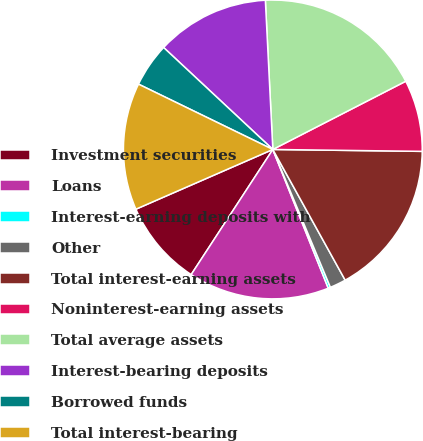Convert chart. <chart><loc_0><loc_0><loc_500><loc_500><pie_chart><fcel>Investment securities<fcel>Loans<fcel>Interest-earning deposits with<fcel>Other<fcel>Total interest-earning assets<fcel>Noninterest-earning assets<fcel>Total average assets<fcel>Interest-bearing deposits<fcel>Borrowed funds<fcel>Total interest-bearing<nl><fcel>9.25%<fcel>15.25%<fcel>0.25%<fcel>1.75%<fcel>16.75%<fcel>7.75%<fcel>18.25%<fcel>12.25%<fcel>4.75%<fcel>13.75%<nl></chart> 